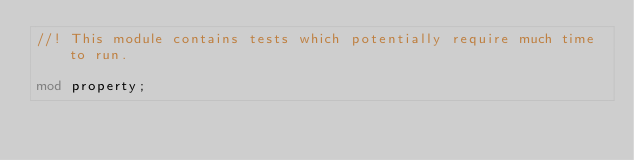Convert code to text. <code><loc_0><loc_0><loc_500><loc_500><_Rust_>//! This module contains tests which potentially require much time to run.

mod property;
</code> 